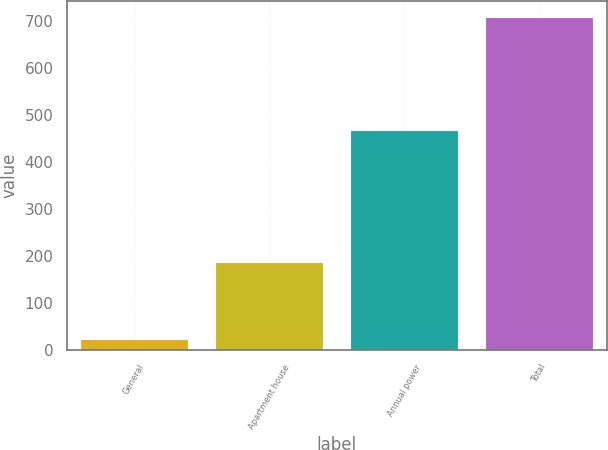Convert chart to OTSL. <chart><loc_0><loc_0><loc_500><loc_500><bar_chart><fcel>General<fcel>Apartment house<fcel>Annual power<fcel>Total<nl><fcel>23<fcel>186<fcel>468<fcel>707<nl></chart> 